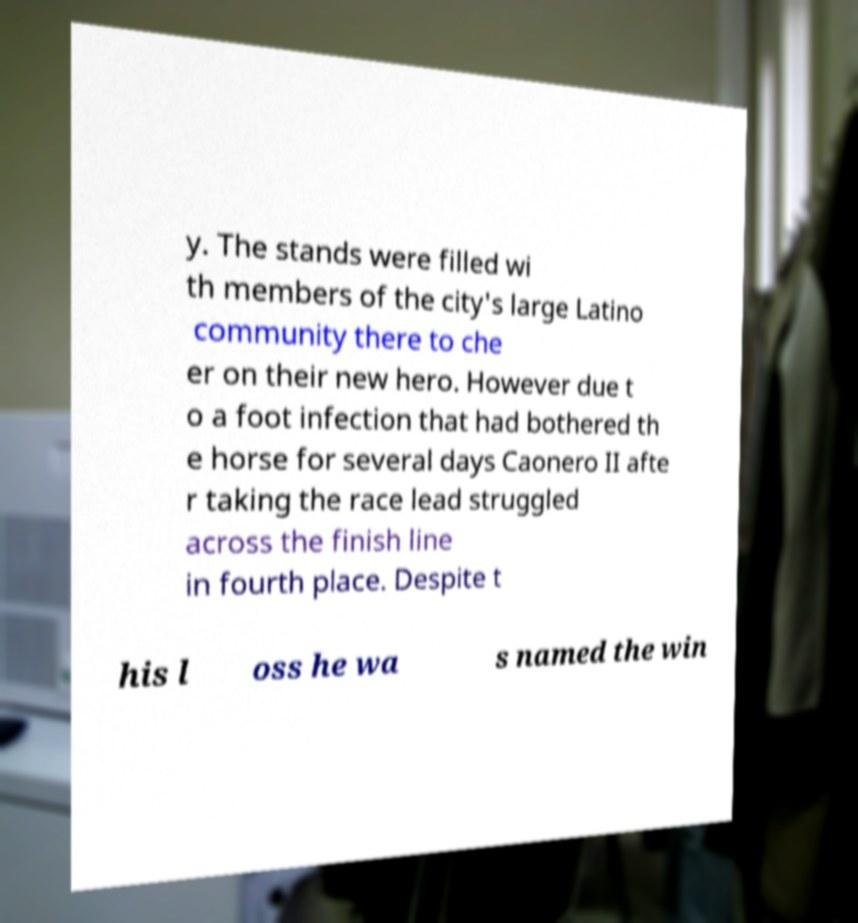Please identify and transcribe the text found in this image. y. The stands were filled wi th members of the city's large Latino community there to che er on their new hero. However due t o a foot infection that had bothered th e horse for several days Caonero II afte r taking the race lead struggled across the finish line in fourth place. Despite t his l oss he wa s named the win 